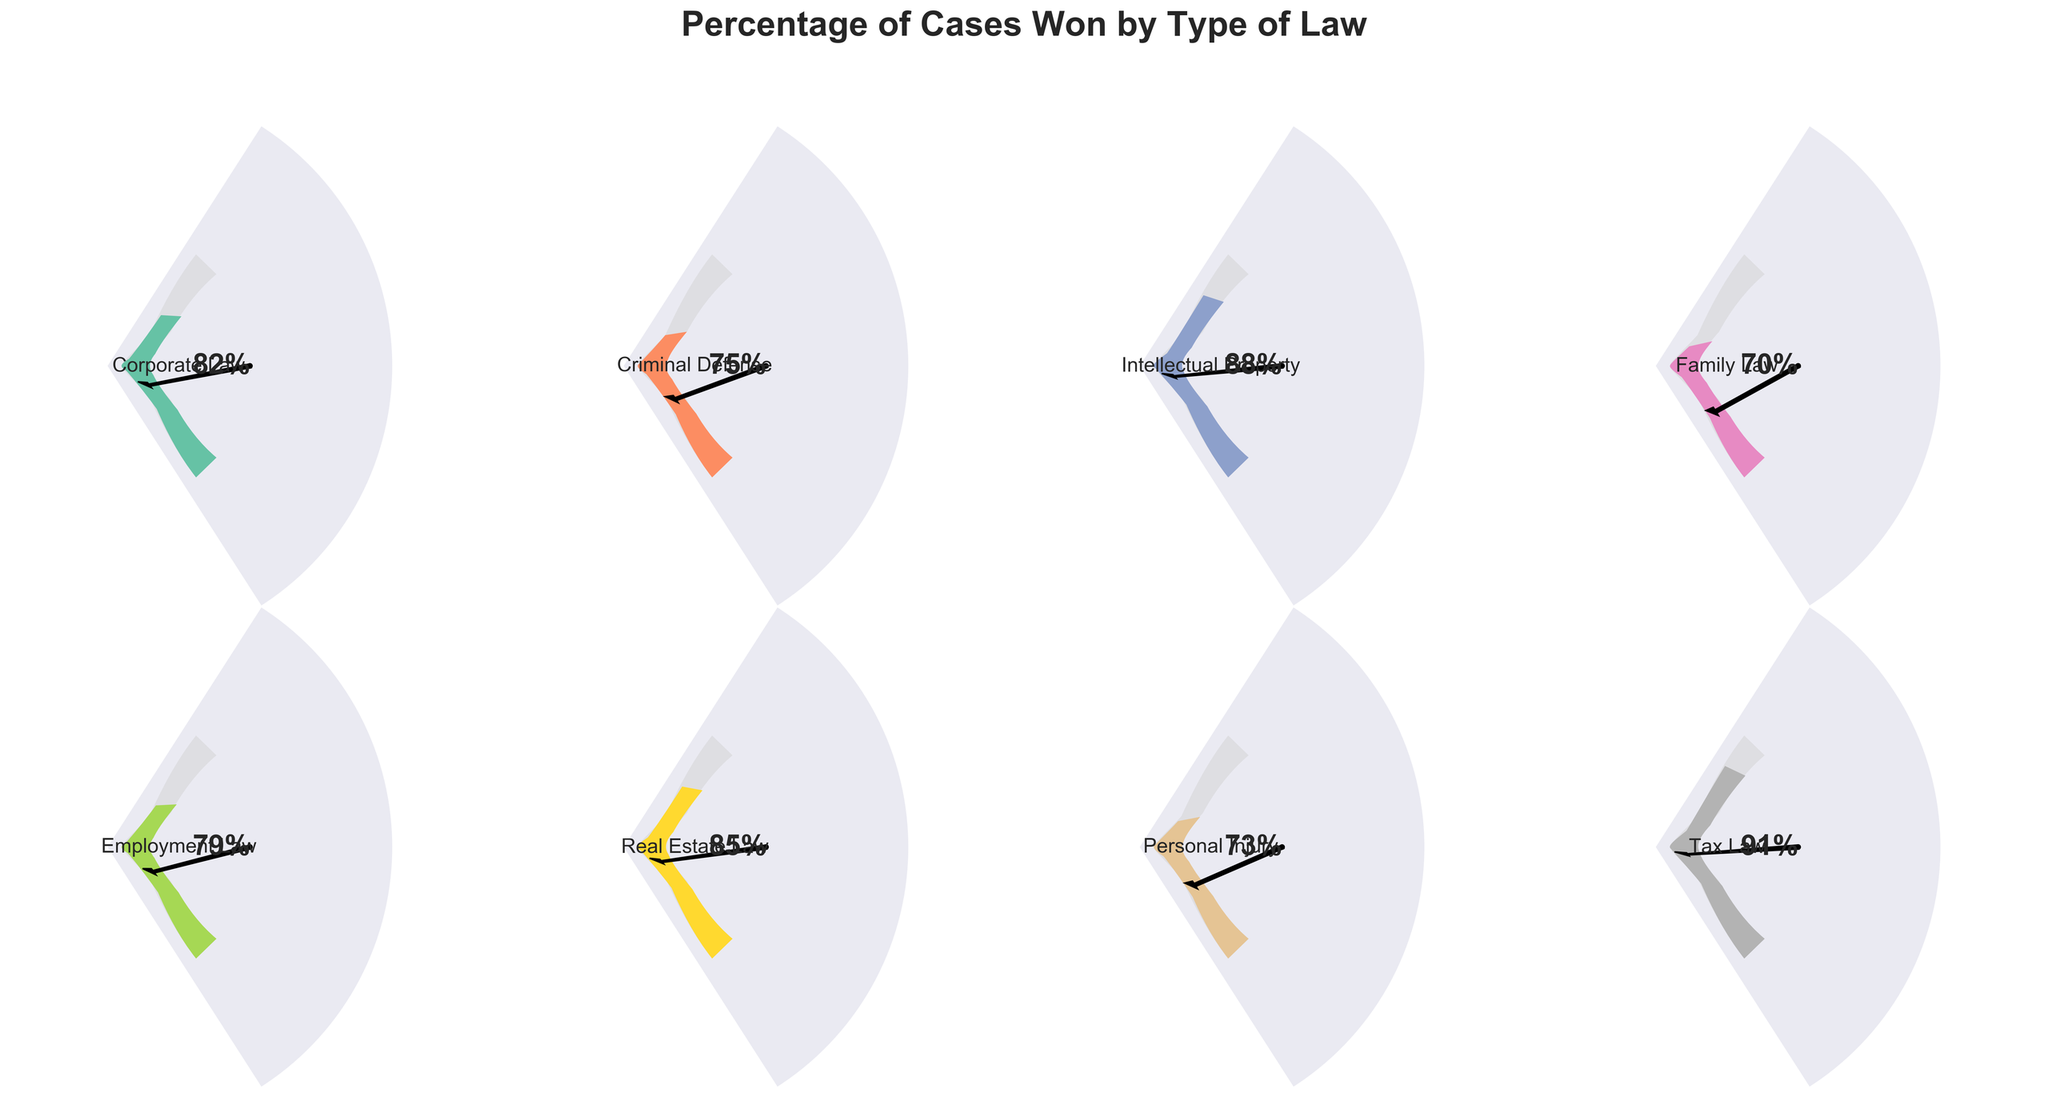what is the title of the figure? The title is located at the top of the figure, set in a large, bold font. It reads "Percentage of Cases Won by Type of Law".
Answer: "Percentage of Cases Won by Type of Law" how many types of law are displayed in the figure? By counting the number of individual gauges or dials in the figure, you can determine there are eight types of law represented.
Answer: Eight which type of law had the highest percentage of cases won? By examining each gauge, the type of law with the highest percentage value is "Tax Law" with 91%.
Answer: Tax Law compare the percentage of cases won in criminal defense and personal injury law. which has a higher value? Criminal defense has a percentage of 75%, while personal injury has 73%. Therefore, criminal defense has a higher percentage of cases won.
Answer: Criminal Defense what is the average percentage of cases won across all types of law? To find the average, sum all the percentages (82 + 75 + 88 + 70 + 79 + 85 + 73 + 91) and then divide by the number of types of law (8). The average is (643 / 8) = 80.38%.
Answer: 80.38% are there any types of law where the percentage of cases won is below 75%? By observing the gauges, the types of law with percentages below 75% are Family Law and Personal Injury Law with 70% and 73% respectively.
Answer: Yes, Family Law and Personal Injury Law how does the percentage of cases won in intellectual property law compare to real estate law? Intellectual Property Law has 88%, while Real Estate Law has 85%. Thus, Intellectual Property Law has a higher percentage of cases won.
Answer: Intellectual Property Law between employment law and corporate law, which has a lower percentage of cases won? Employment Law has 79%, and Corporate Law has 82%. Thus, Employment Law has a lower percentage.
Answer: Employment Law what is the range of percentages of cases won across all types of law? The lowest percentage is in Family Law (70%) and the highest is in Tax Law (91%), giving a range of 91% - 70% = 21%.
Answer: 21% in the gauge for criminal defense, what is the percentage value indicated by the pointer? By looking at the pointer in the Criminal Defense gauge, it is angled at 75%.
Answer: 75% 